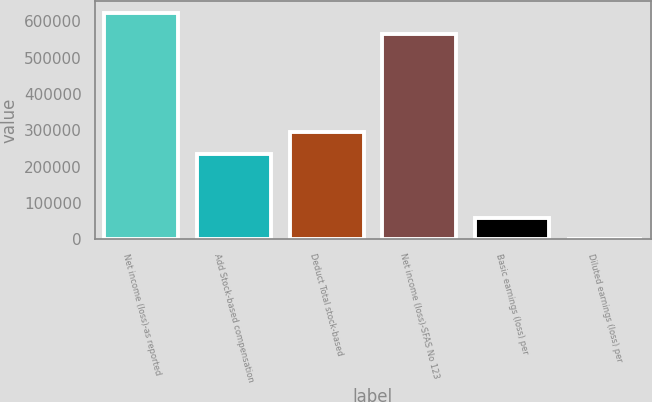Convert chart. <chart><loc_0><loc_0><loc_500><loc_500><bar_chart><fcel>Net income (loss)-as reported<fcel>Add Stock-based compensation<fcel>Deduct Total stock-based<fcel>Net income (loss)-SFAS No 123<fcel>Basic earnings (loss) per<fcel>Diluted earnings (loss) per<nl><fcel>623832<fcel>235381<fcel>294226<fcel>564987<fcel>58846.3<fcel>1.33<nl></chart> 